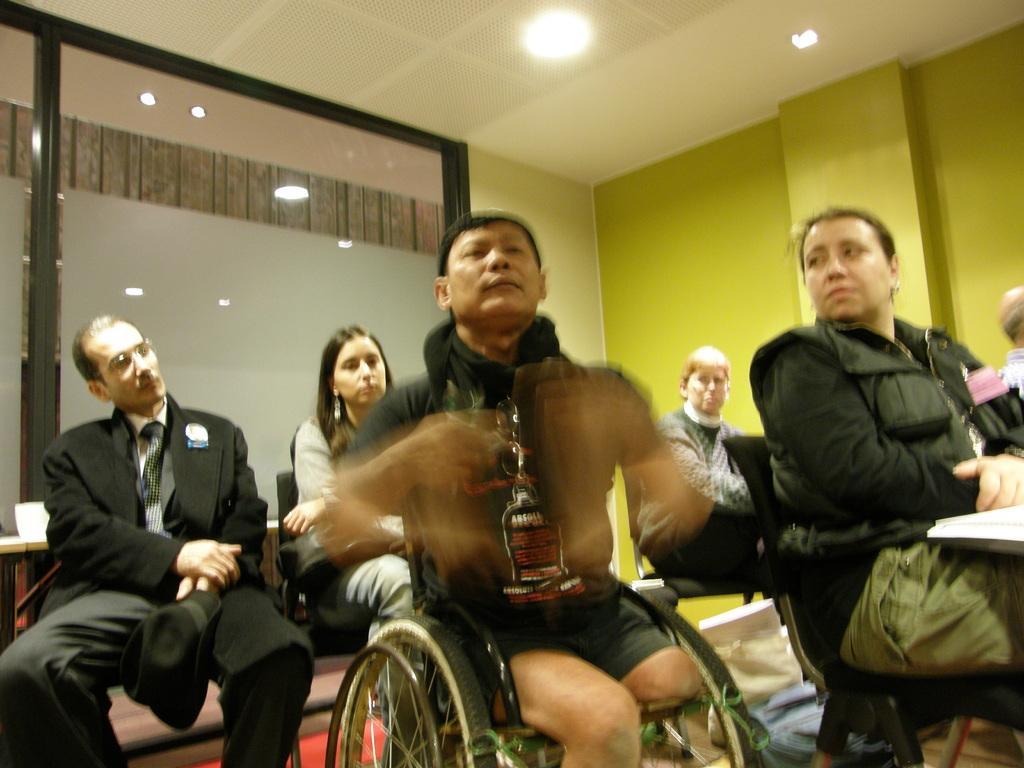Describe this image in one or two sentences. In this image there are a few people sitting on the chairs. There are tables. On top of it there are some objects. In the background of the image there is a mirror and a wall. On top of the image there are lights. 